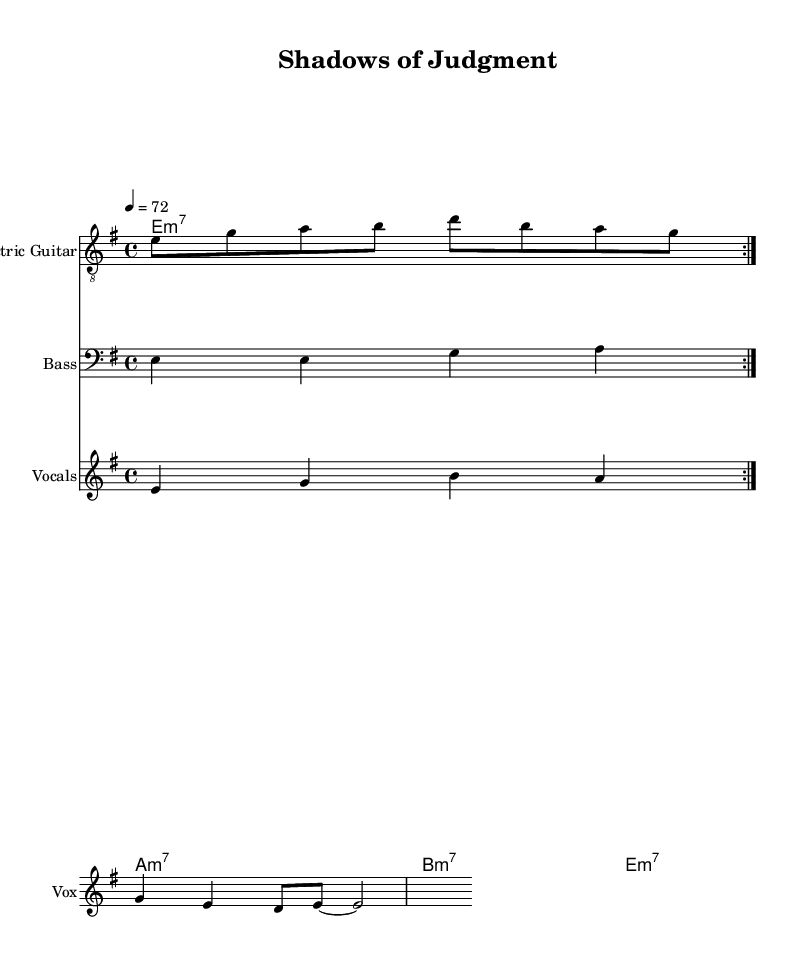What is the key signature of this music? The key signature is E minor, which has one sharp (F#). This can be identified at the beginning of the staff, where the key signature is shown.
Answer: E minor What is the time signature of this piece? The time signature is displayed at the beginning of the piece as 4/4, indicating that there are four beats in each measure and the quarter note gets one beat.
Answer: 4/4 What is the tempo marking for this music? The tempo marking is indicated at the beginning with the notation 4 = 72, which specifies that the quarter note should be played at a speed of 72 beats per minute.
Answer: 72 How many verses are presented in the lyrics? The lyrics section contains one verse as indicated by the single line of text under the melody notation in the score.
Answer: One verse What type of chords are used in the organ accompaniment? The organ chords displayed in the score indicate minor seventh chords (m7), specified through the chordmode foundational symbols at the start of the organ section.
Answer: Minor seventh chords What does the repeated structure in the electric guitar part suggest about the style? The repeated volta in the electric guitar part indicates a typical feature of blues music, emphasizing a cyclical form that is common in electric blues where themes are revisited and elaborated upon.
Answer: Cyclical form 